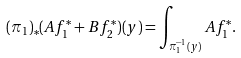Convert formula to latex. <formula><loc_0><loc_0><loc_500><loc_500>( \pi _ { 1 } ) _ { * } ( A f _ { 1 } ^ { * } + B f _ { 2 } ^ { * } ) ( y ) = \int _ { \pi _ { 1 } ^ { - 1 } ( y ) } A f _ { 1 } ^ { * } .</formula> 